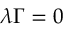Convert formula to latex. <formula><loc_0><loc_0><loc_500><loc_500>{ \lambda \Gamma } = 0</formula> 